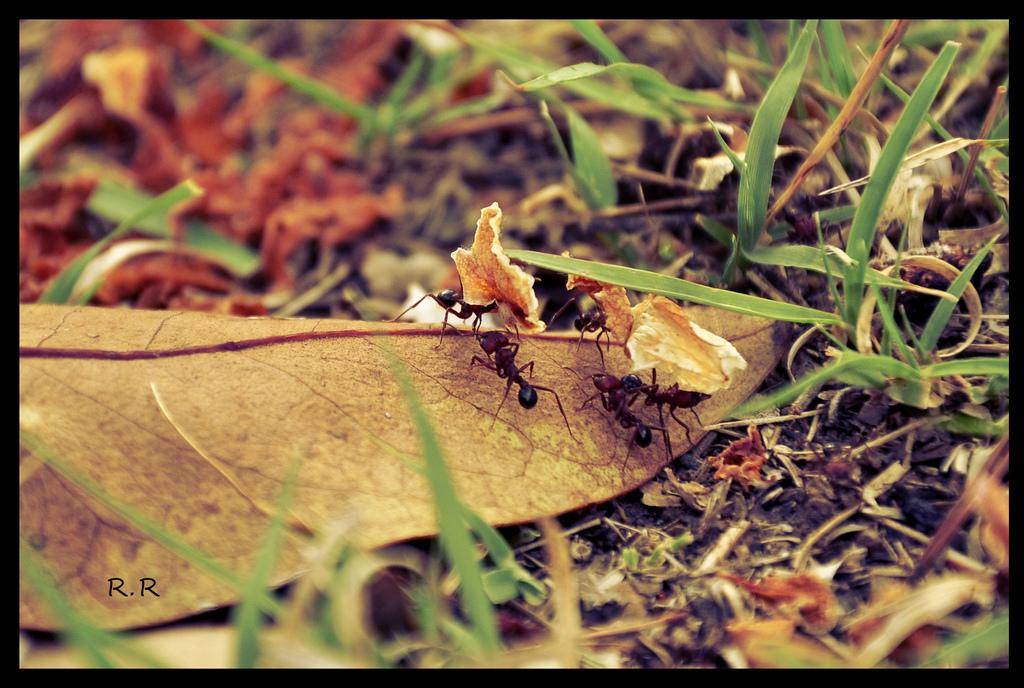What is present on the ground in the image? There is grass on the ground in the image. What else can be seen on the ground besides grass? There are other items on the ground in the image. What is the main subject of the image? The main subject of the image is a dry leaf. What is happening on the leaf? There are black ants on the leaf, and they are walking on it. What are the ants carrying with them? The ants are taking something with them. How does the lettuce feel about the ants in the image? There is no lettuce present in the image, so it cannot have any feelings about the ants. 